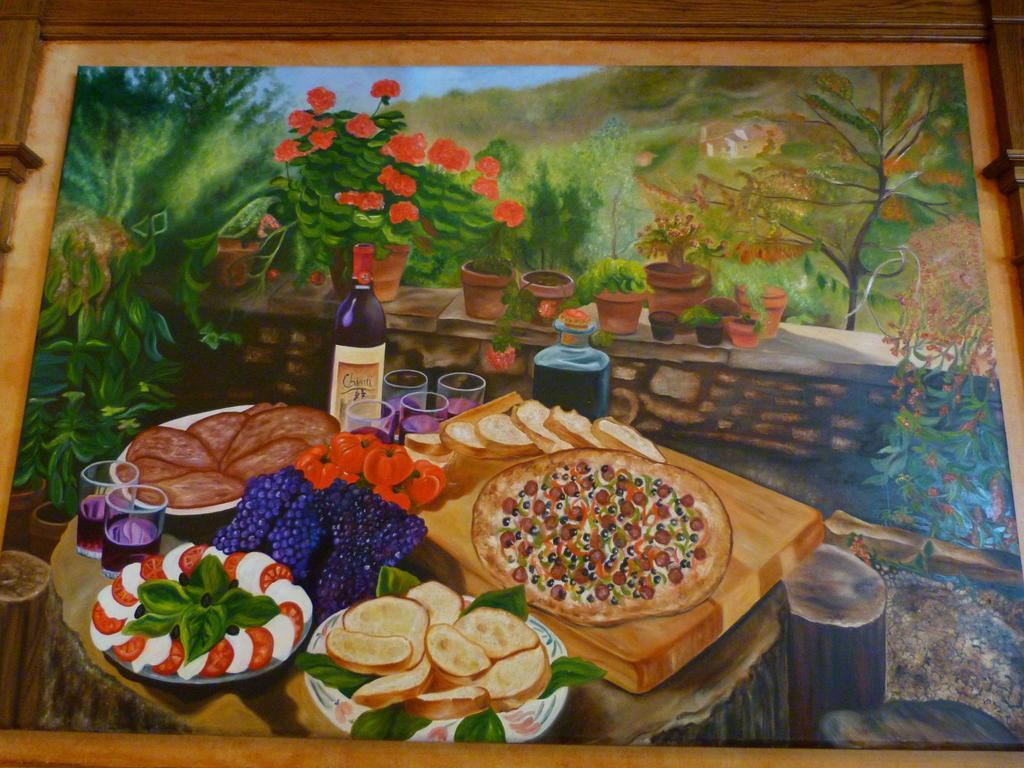What is depicted in the painting in the image? The painting in the image contains food items. What else can be seen in the image besides the painting? There are glasses with drinks and bottles in the image. Are there any decorative elements in the image? Yes, there are flower pots in the image. What can be seen in the background of the image? Trees are visible on the frame of the image. What type of music is the band playing in the image? There is no band present in the image, so it is not possible to determine what type of music they might be playing. 